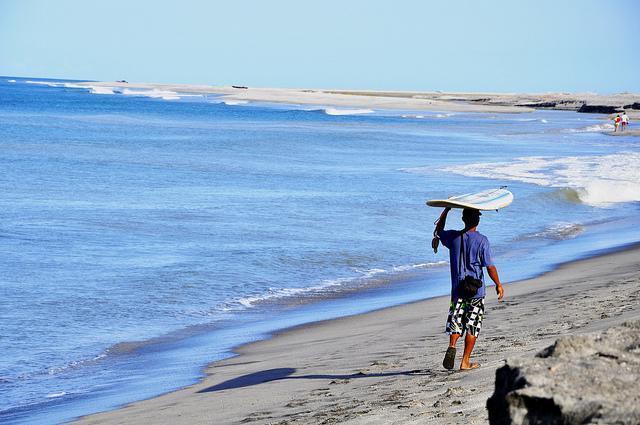How many waves are hitting the beach?
Give a very brief answer. 1. 